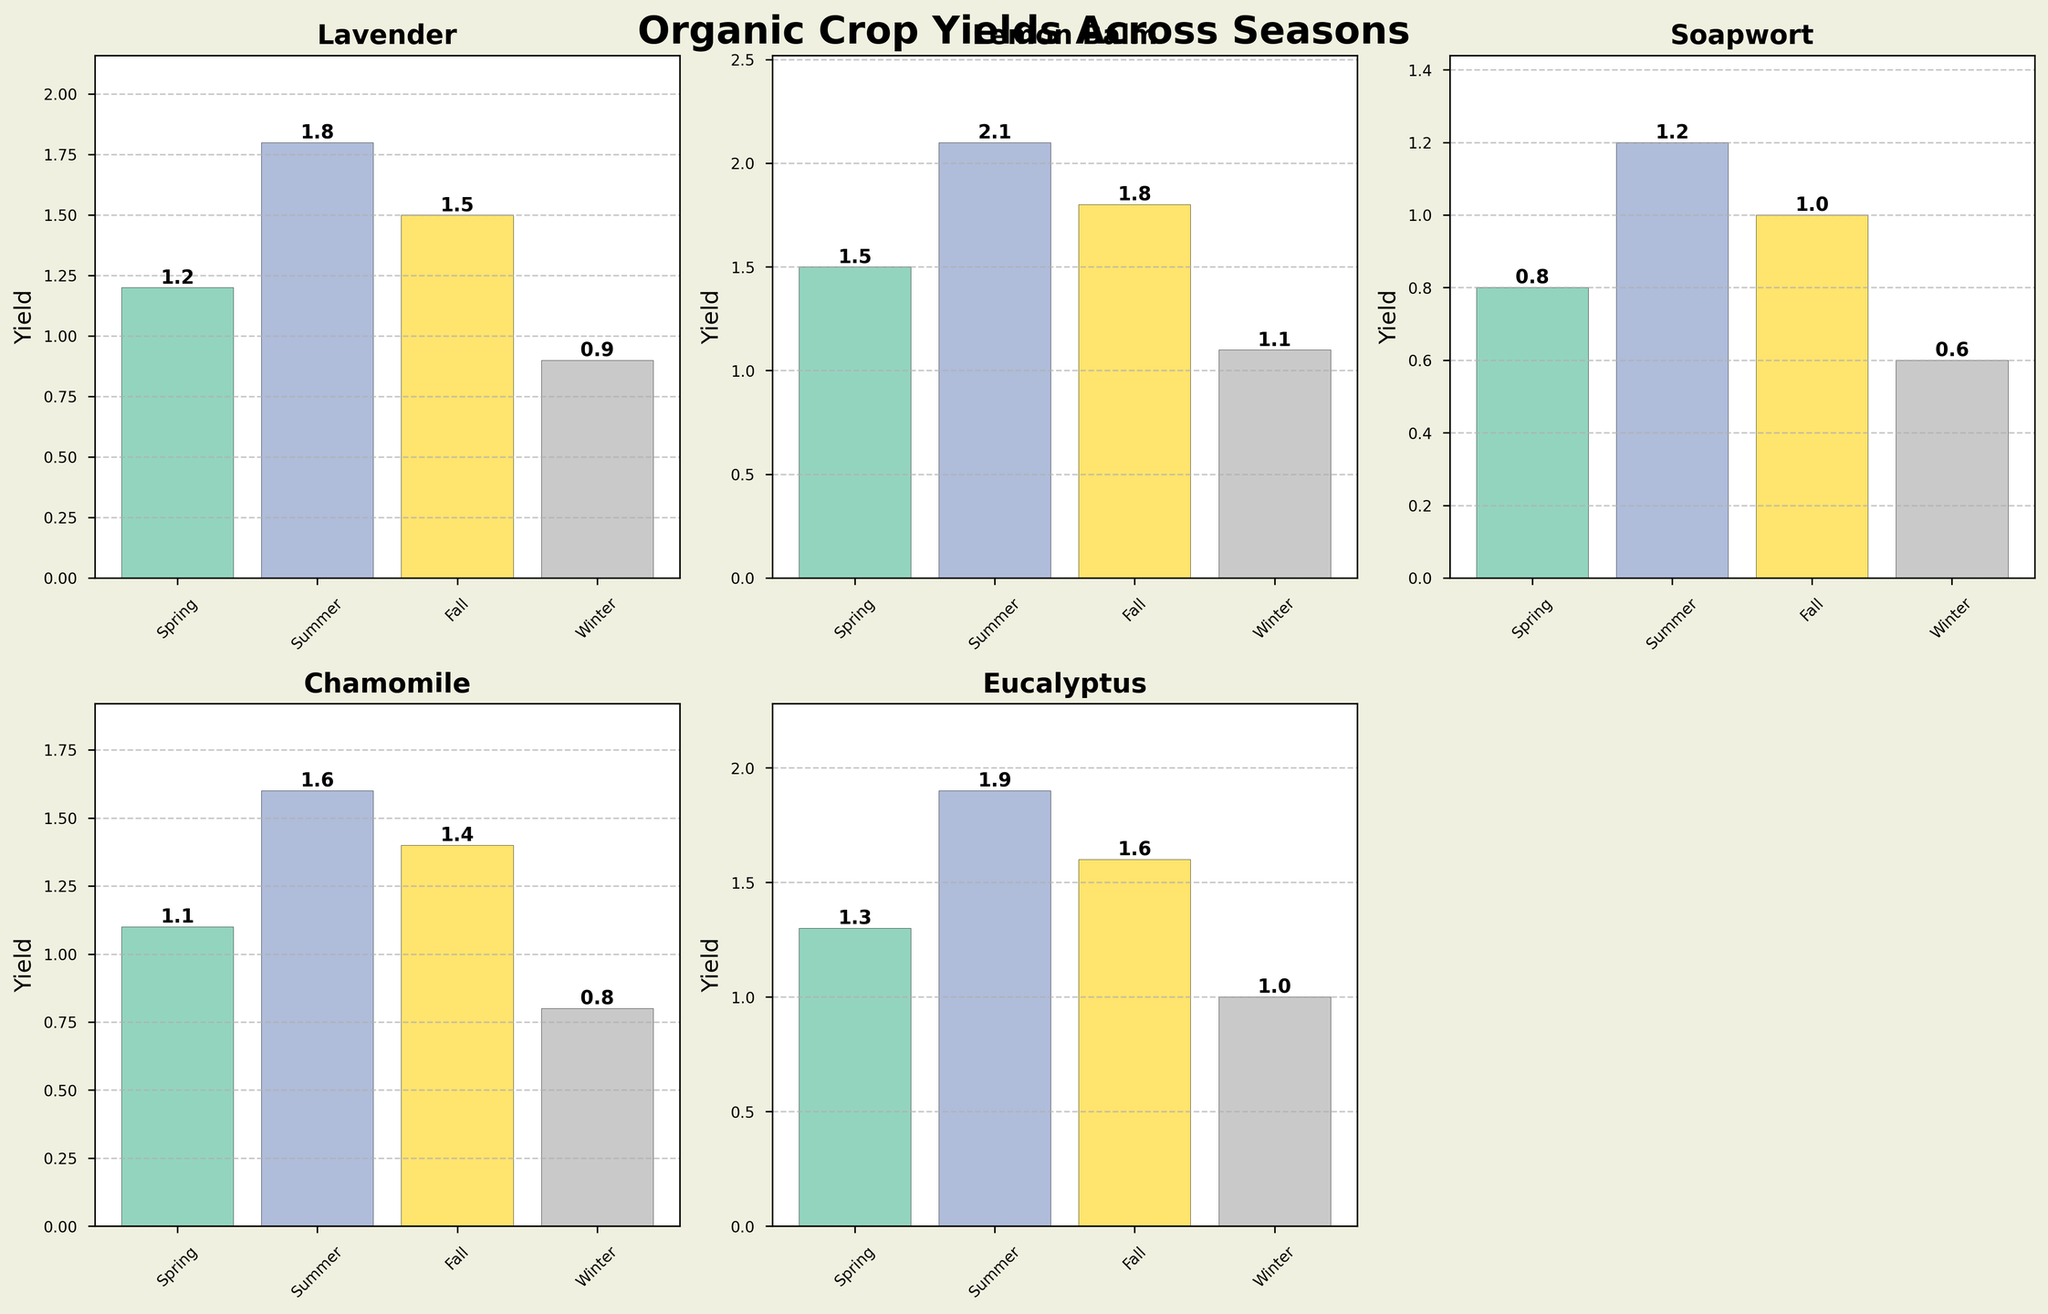What's the title of the figure? The title is usually located at the top center of the plot. In this figure, it is "Organic Crop Yields Across Seasons".
Answer: Organic Crop Yields Across Seasons Which crop has the highest yield in Summer? In the subplot for Summer, the tallest bar corresponds to Lemon Balm with a yield of 2.1.
Answer: Lemon Balm What is the average yield of Soapwort over all seasons? Sum the yields of Soapwort for all seasons (0.8 + 1.2 + 1.0 + 0.6) and divide by the number of seasons (4). The average yield is (0.8 + 1.2 + 1.0 + 0.6) / 4 = 3.6 / 4 = 0.9.
Answer: 0.9 Which season has the lowest yield for Chamomile? In the subplots, the lowest bar for Chamomile is in Winter with a yield of 0.8.
Answer: Winter Compare the yields of Eucalyptus between Spring and Fall. Which is higher and by how much? Eucalyptus yields in Spring and Fall are 1.3 and 1.6 respectively. The yield is higher in Fall by 1.6 - 1.3 = 0.3.
Answer: Fall, by 0.3 What is the trend of Lavender yields from Spring to Winter? Observing the Lavender subplot, the yields are 1.2 (Spring), 1.8 (Summer), 1.5 (Fall), 0.9 (Winter). The yields first increase from Spring to Summer, then decrease from Summer to Winter.
Answer: Increase, then decrease Which crop has the highest yield in Fall? In the subplot for Fall, the tallest bar corresponds to Lemon Balm with a yield of 1.8.
Answer: Lemon Balm What is the total yield of Chamomile over all seasons? Sum the yields of Chamomile for all seasons (1.1 + 1.6 + 1.4 + 0.8). The total yield is 1.1 + 1.6 + 1.4 + 0.8 = 4.9.
Answer: 4.9 Is there any crop that has a consistent increase or decrease in yield across all the seasons? Reviewing each subplot for trends, no crop shows a consistently increasing or decreasing pattern from Spring to Winter in all the subplots.
Answer: No 